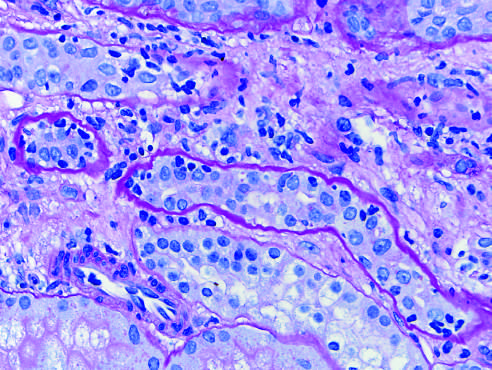how is acute cellular rejection of a kidney graft manifested?
Answer the question using a single word or phrase. By inflammatory cells in the inter-stitium and between epithelial cells of the tubules tubulitis 